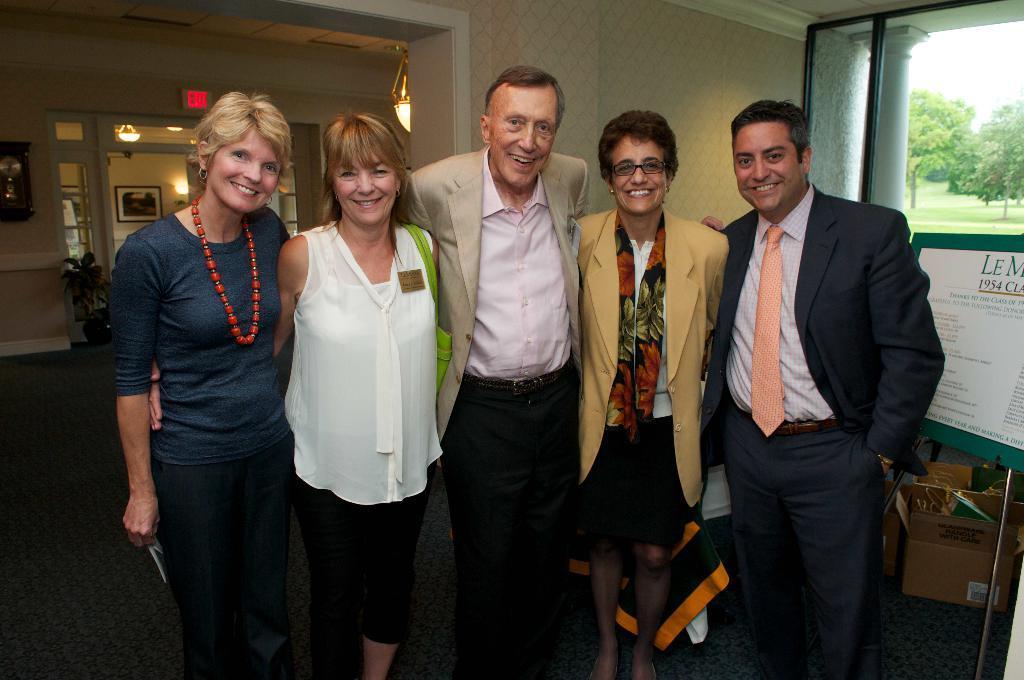Could you give a brief overview of what you see in this image? In the center of the image we can see people standing and smiling. In the background there is a board, cardboard boxes and a window. At the top there are chandeliers and we can see a decor placed on the wall. There is a plant. 